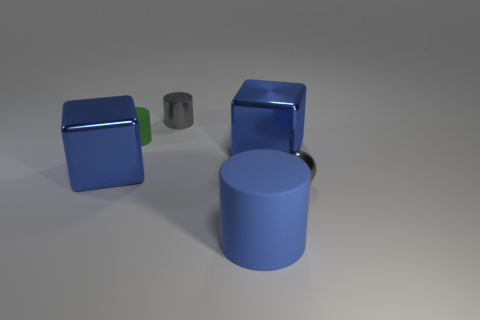Add 3 tiny red rubber cylinders. How many objects exist? 9 Subtract all spheres. How many objects are left? 5 Subtract all tiny metal cylinders. Subtract all green matte cylinders. How many objects are left? 4 Add 3 gray balls. How many gray balls are left? 4 Add 6 big matte cylinders. How many big matte cylinders exist? 7 Subtract 0 green blocks. How many objects are left? 6 